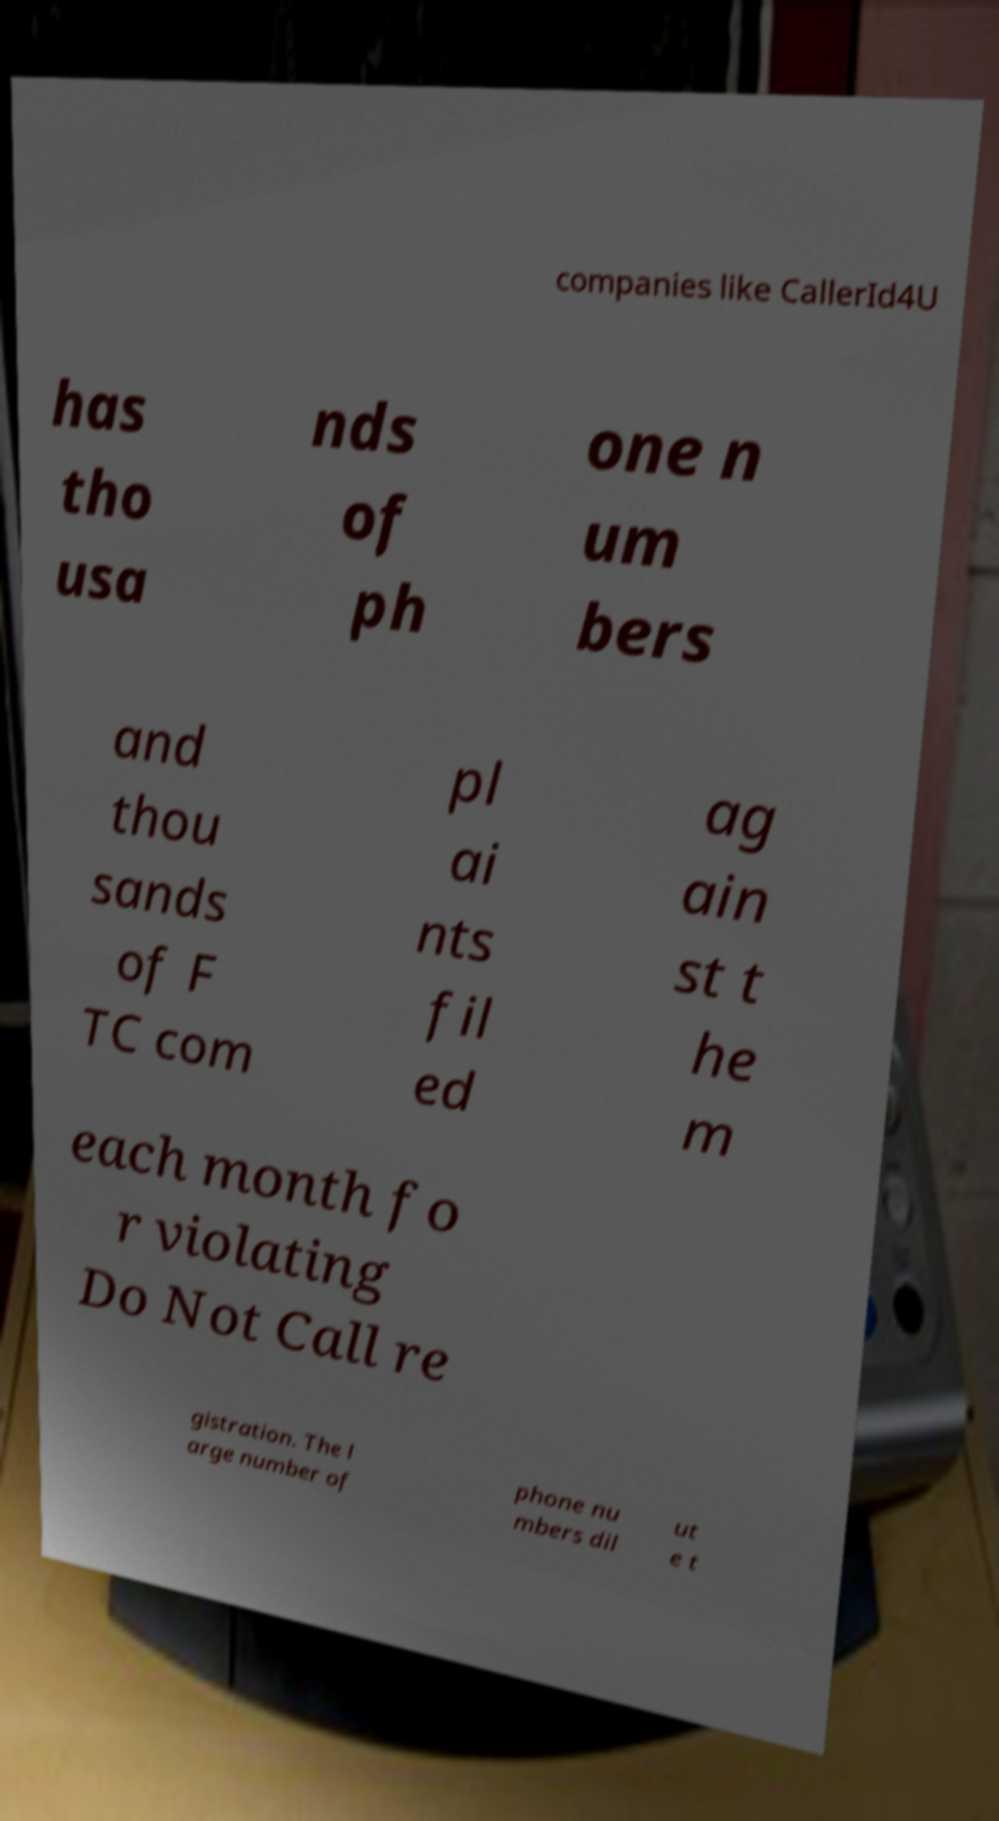Please read and relay the text visible in this image. What does it say? companies like CallerId4U has tho usa nds of ph one n um bers and thou sands of F TC com pl ai nts fil ed ag ain st t he m each month fo r violating Do Not Call re gistration. The l arge number of phone nu mbers dil ut e t 